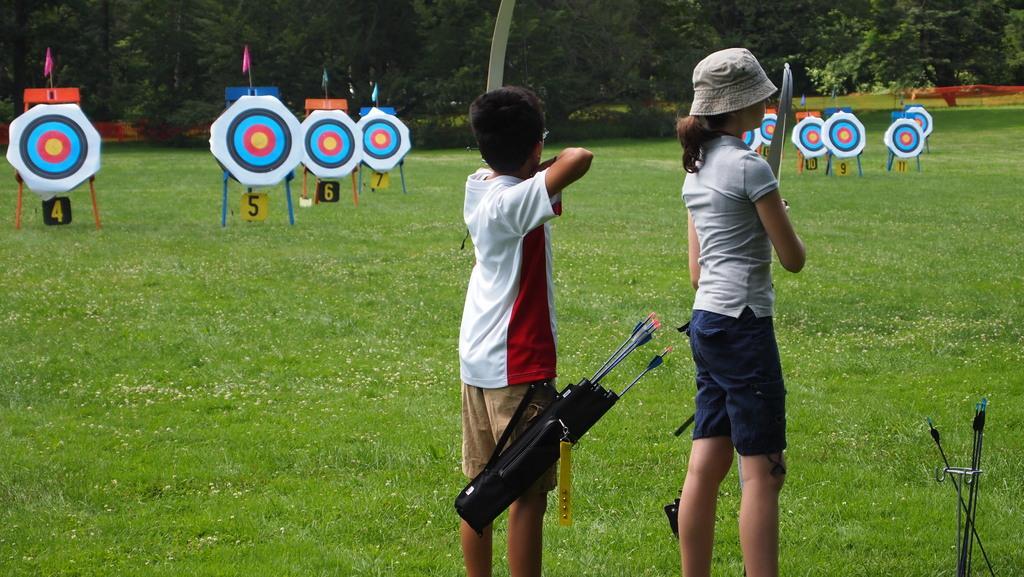Can you describe this image briefly? In this image I can see a boy wearing white and red colored t shirt and brown colored short is standing and I can see a black colored object to his short. I can see a girl wearing hat, ash colored top and blue colored short is standing and they are holding bows in their hands. In the background I can see some grass, few trees, few flags and few other objects. 